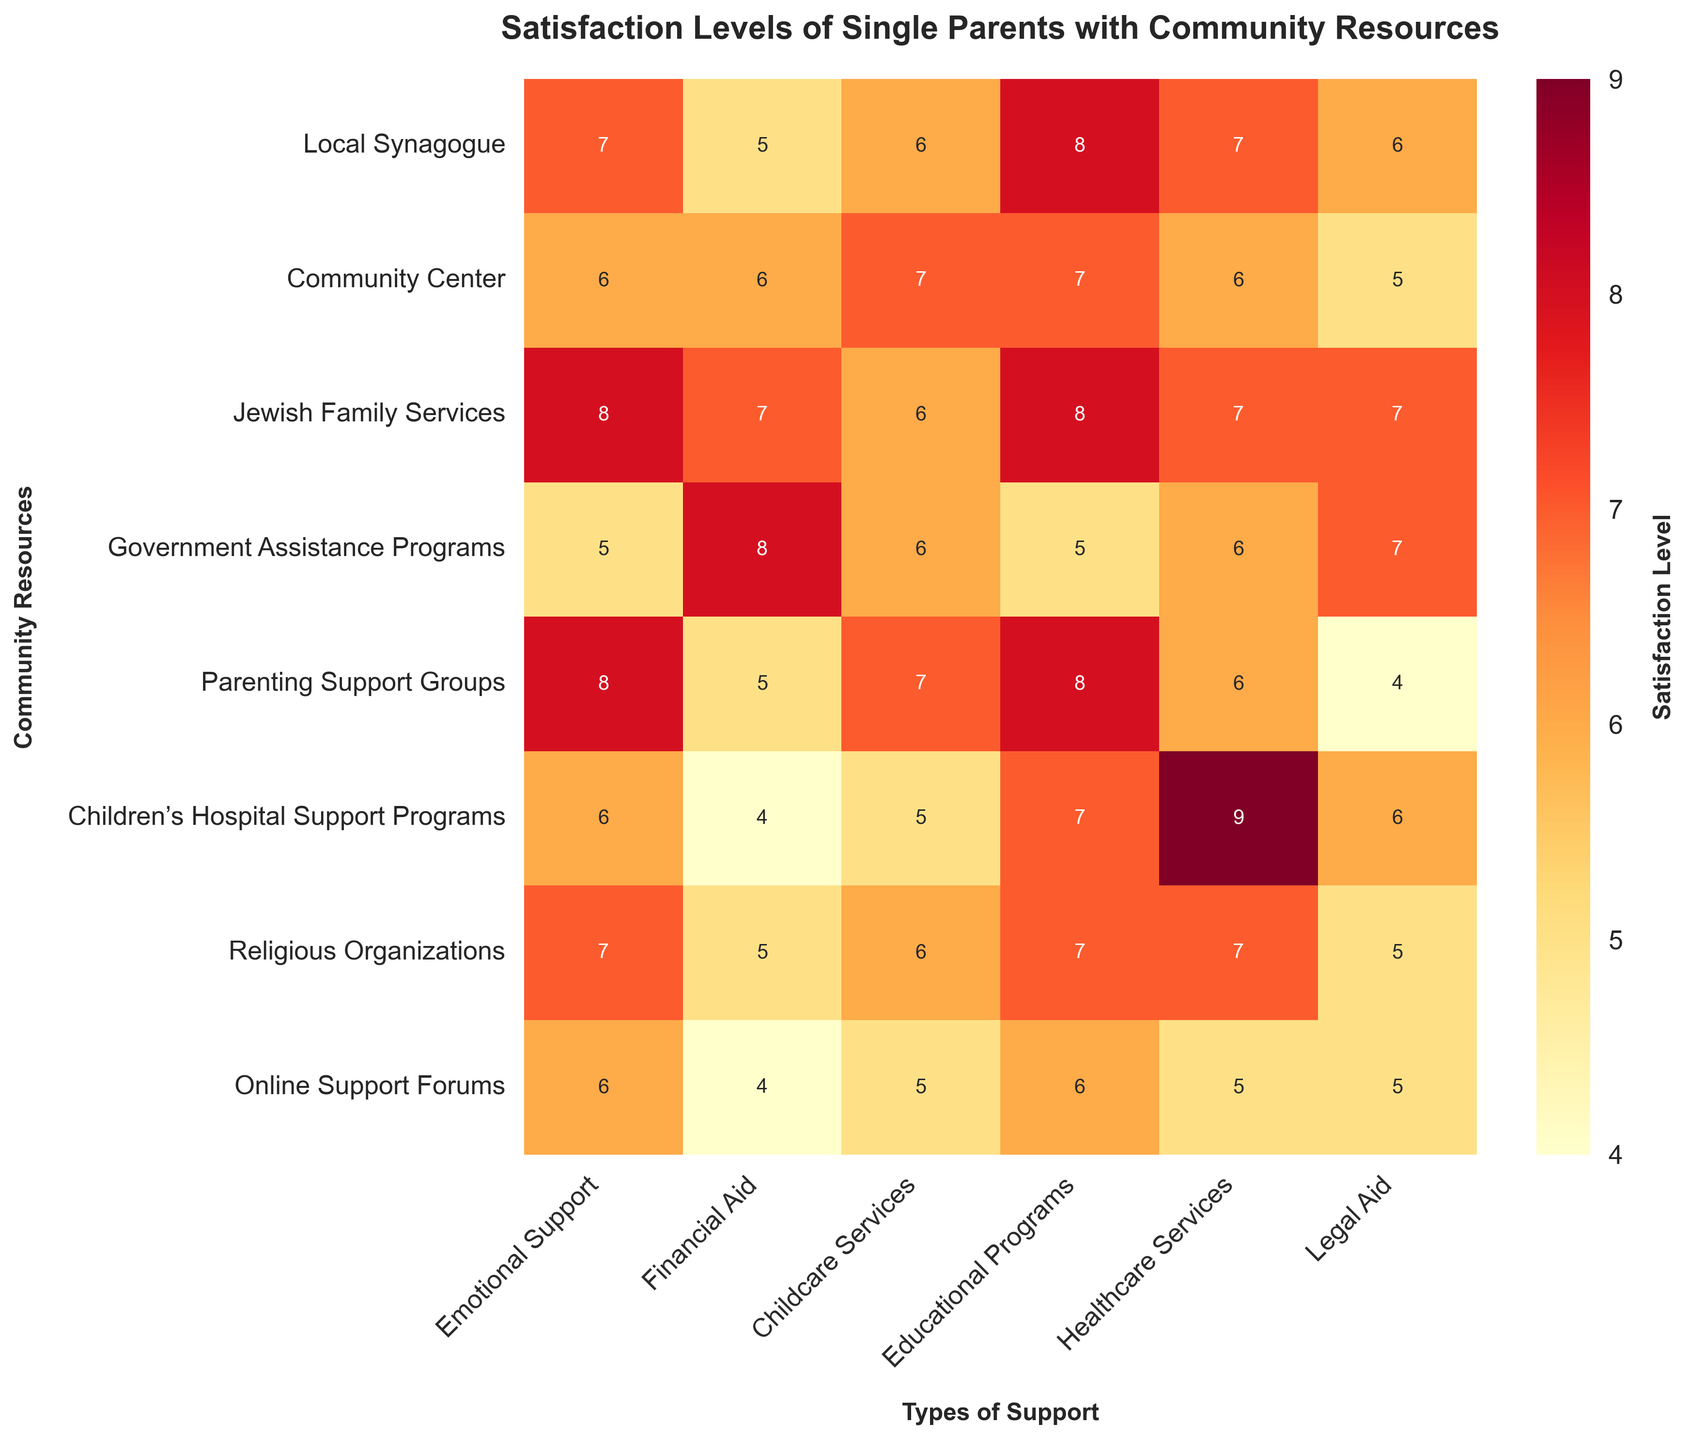What is the title of the heatmap? The title is located at the top of the heatmap, usually in larger font and bold. This title summarizes the content of the heatmap.
Answer: Satisfaction Levels of Single Parents with Community Resources Which community resource is most satisfactory in terms of Emotional Support? Look for the highest number in the column labeled "Emotional Support" and find the corresponding row.
Answer: Jewish Family Services and Parenting Support Groups What type of support has the highest satisfaction level for Children’s Hospital Support Programs? Look for the highest number in the row labeled "Children’s Hospital Support Programs" and note the corresponding column header.
Answer: Healthcare Services Which two community resources have the same satisfaction level for Legal Aid? Identify columns where the values are repeated. Check the row "Legal Aid" for repeating values and note the corresponding resources.
Answer: Community Center and Religious Organizations What is the total satisfaction level for Local Synagogue across all types of support? Sum up all the values in the row labeled "Local Synagogue."
Answer: 39 Which support type has the lowest satisfaction level across different resources? Scan through all support types and identify the lowest number, then note the support type.
Answer: Emotional Support (4) What is the maximum satisfaction level for Online Support Forums and for which support type? Look at the row labeled "Online Support Forums" and identify the highest number along with the corresponding support type.
Answer: Emotional Support, 6 Are there any community resources that have the same satisfaction level across all types of support? Compare all values within each row to check for equal numbers.
Answer: No 